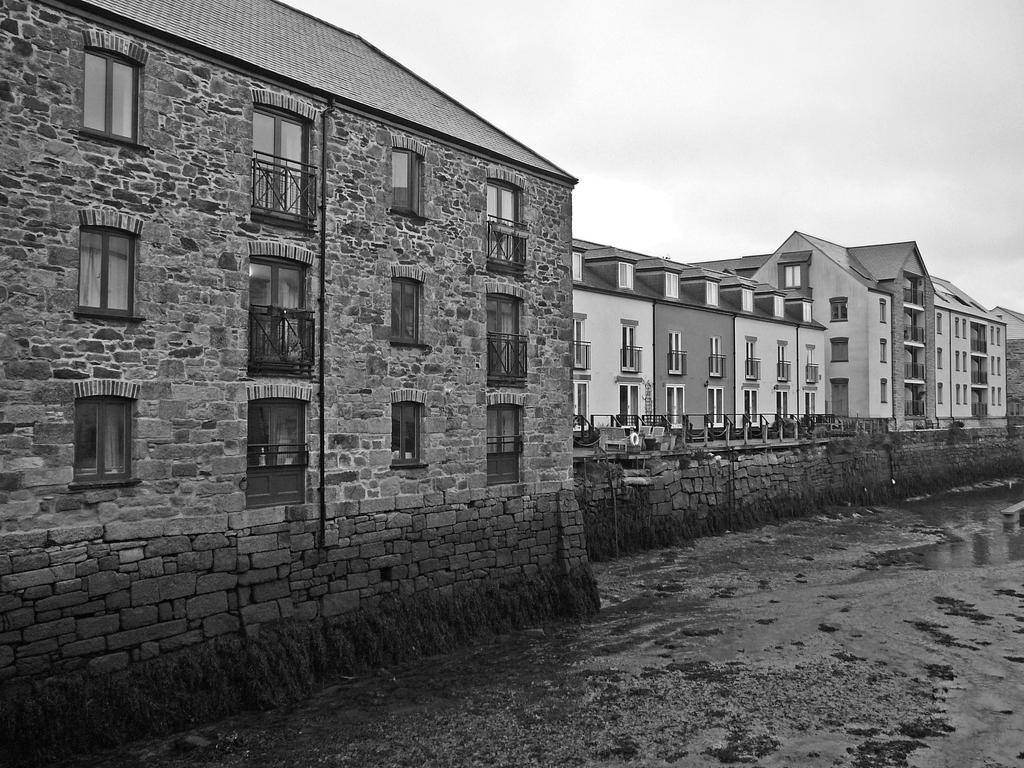What type of structures are present in the image? There are buildings in the image. What are some features of the buildings? The buildings have walls, windows, and railing. What can be seen at the bottom of the image? There is water visible at the bottom of the image. What is visible in the background of the image? The sky is visible in the background of the image. What type of glue is being used to hold the buildings together in the image? There is no glue present in the image; the buildings are constructed with materials like bricks, concrete, or steel. What school is depicted in the image? There is no school present in the image; it features buildings that may or may not be associated with a school. 